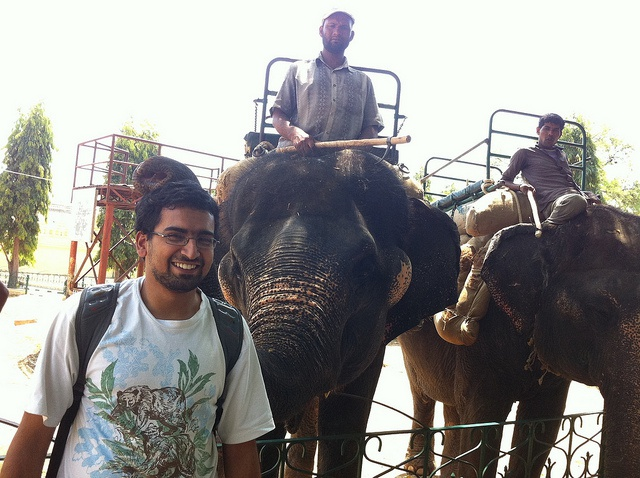Describe the objects in this image and their specific colors. I can see elephant in ivory, black, and gray tones, people in ivory, gray, darkgray, black, and maroon tones, elephant in ivory, black, white, and gray tones, people in ivory, gray, darkgray, and white tones, and people in ivory, gray, black, white, and darkgray tones in this image. 